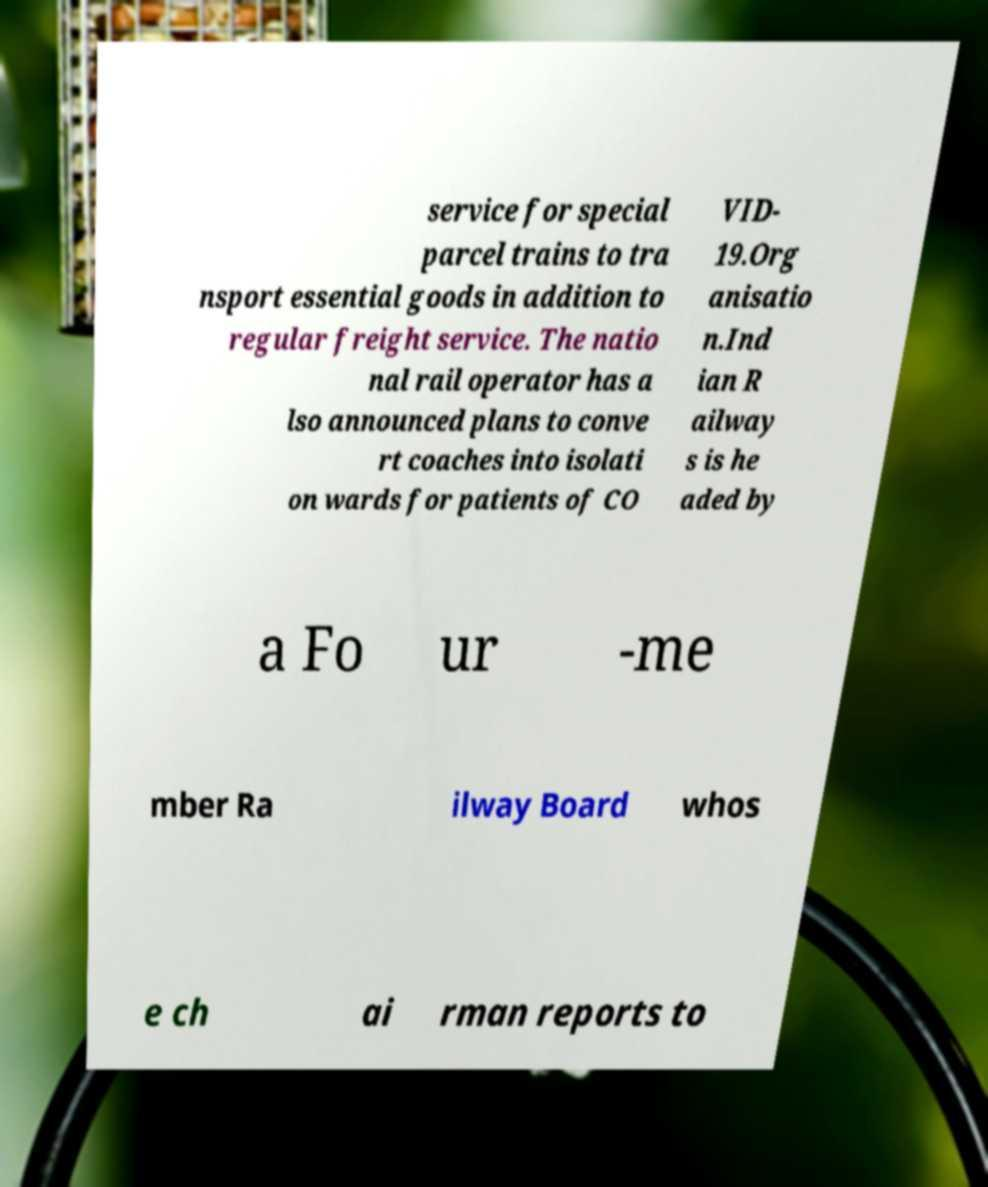Please read and relay the text visible in this image. What does it say? service for special parcel trains to tra nsport essential goods in addition to regular freight service. The natio nal rail operator has a lso announced plans to conve rt coaches into isolati on wards for patients of CO VID- 19.Org anisatio n.Ind ian R ailway s is he aded by a Fo ur -me mber Ra ilway Board whos e ch ai rman reports to 